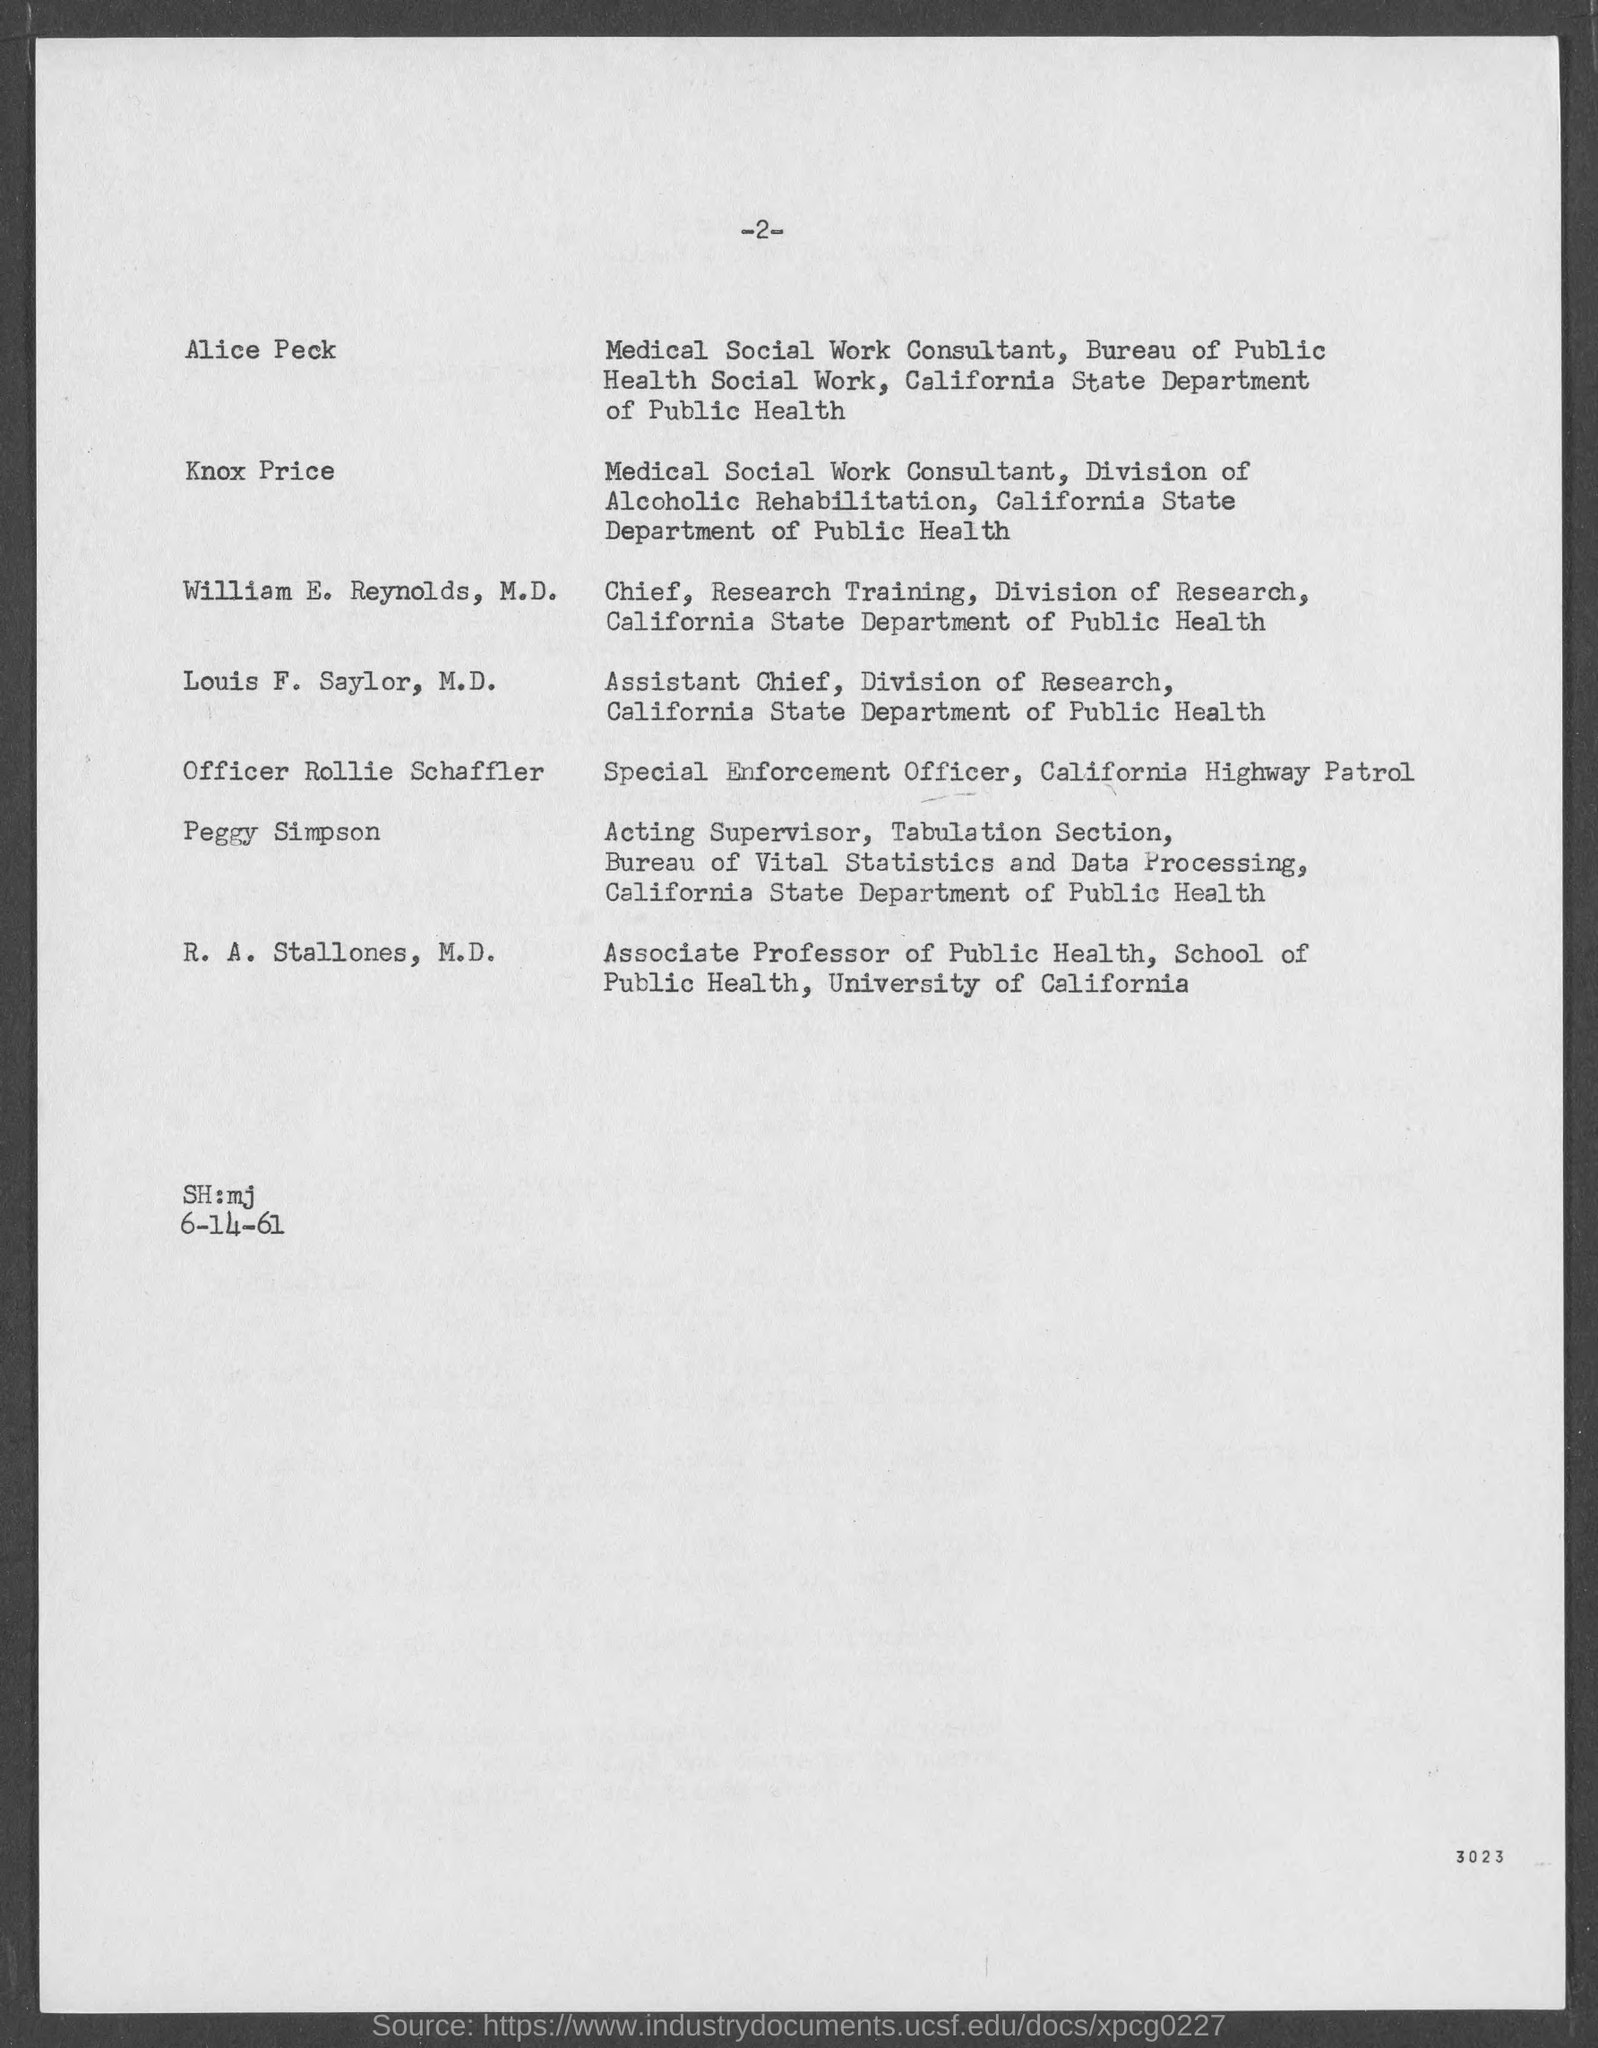Outline some significant characteristics in this image. The date provided is 6-14-61. Knox Price is the name of a Medical Social Work consultant who works for the Division of Alcoholic Rehabilitation at the California State Department of Public Health. The name of the Medical Social Work consultant at the Bureau of Public Health Social Work within the California State Department of Public Health is Alice Peck. Louis F. Saylor, M.D., is known as the Assistant Chief of the Division of Research at the California State Department of Public Health. The name of the individual who serves as the Chief of Research Training for the Division of Research at the California State Department of Public Health is William E. Reynolds, M.D. 